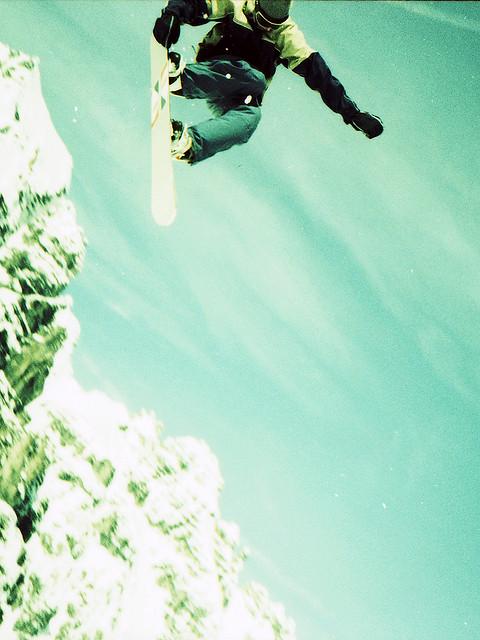What color is the water?
Short answer required. Blue. Is the snowboard in the air?
Short answer required. Yes. What is the man doing?
Be succinct. Snowboarding. Is this man wearing gloves?
Concise answer only. Yes. 